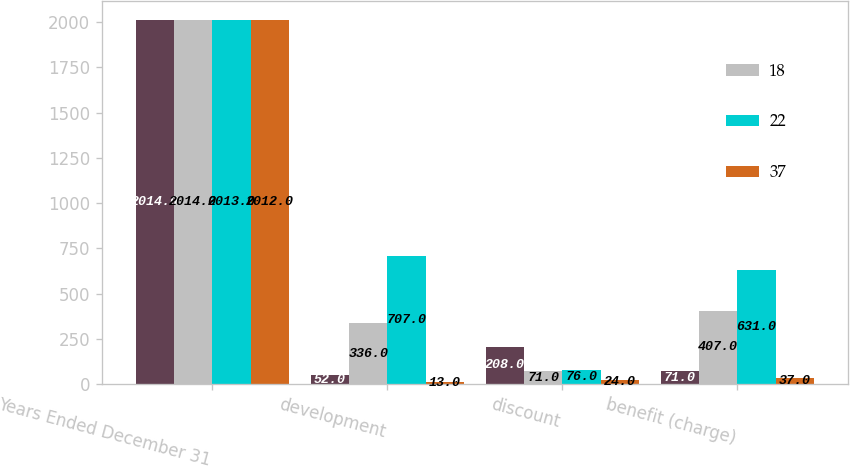Convert chart to OTSL. <chart><loc_0><loc_0><loc_500><loc_500><stacked_bar_chart><ecel><fcel>Years Ended December 31<fcel>development<fcel>discount<fcel>benefit (charge)<nl><fcel>nan<fcel>2014<fcel>52<fcel>208<fcel>71<nl><fcel>18<fcel>2014<fcel>336<fcel>71<fcel>407<nl><fcel>22<fcel>2013<fcel>707<fcel>76<fcel>631<nl><fcel>37<fcel>2012<fcel>13<fcel>24<fcel>37<nl></chart> 